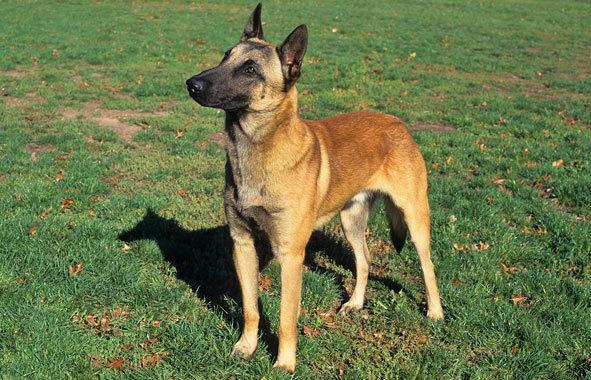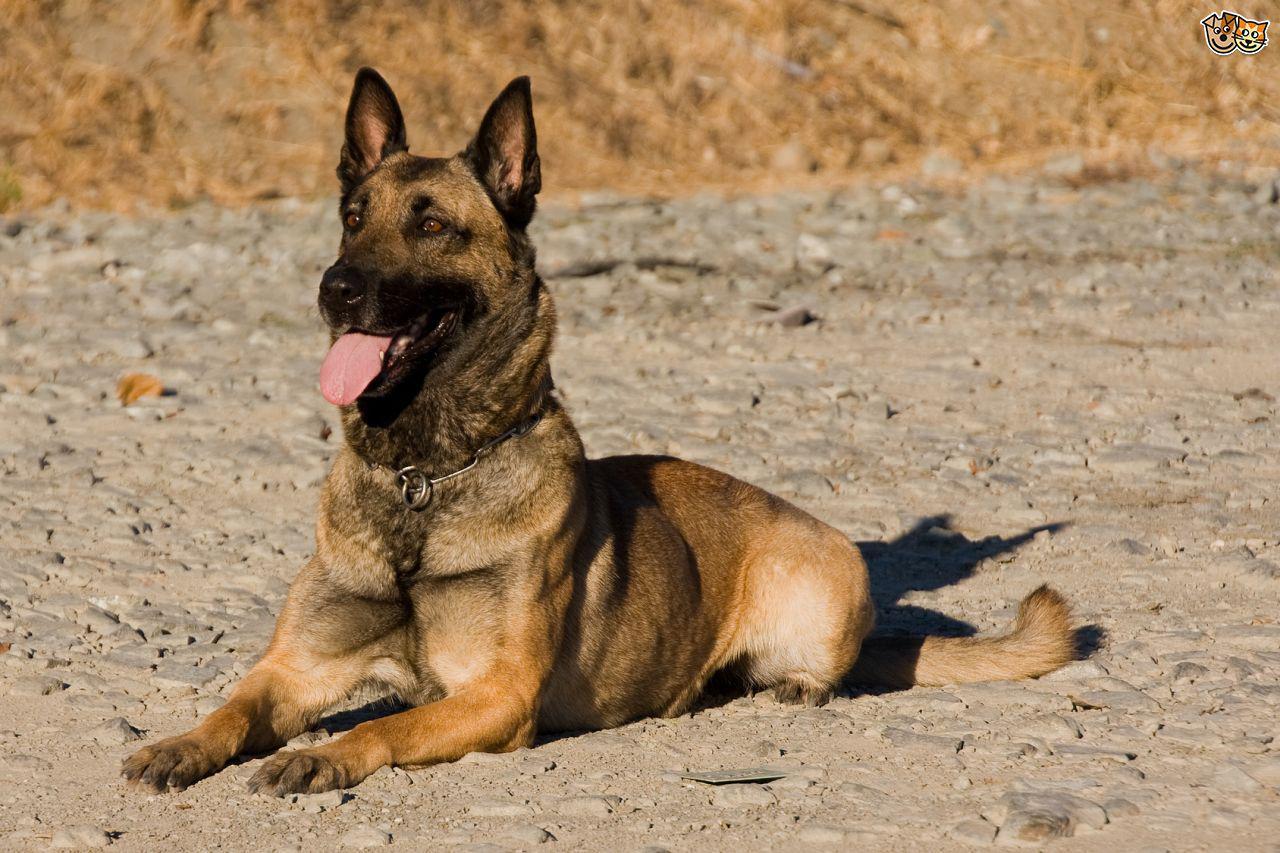The first image is the image on the left, the second image is the image on the right. Evaluate the accuracy of this statement regarding the images: "An image shows a dog sitting upright in grass, wearing a leash.". Is it true? Answer yes or no. No. 